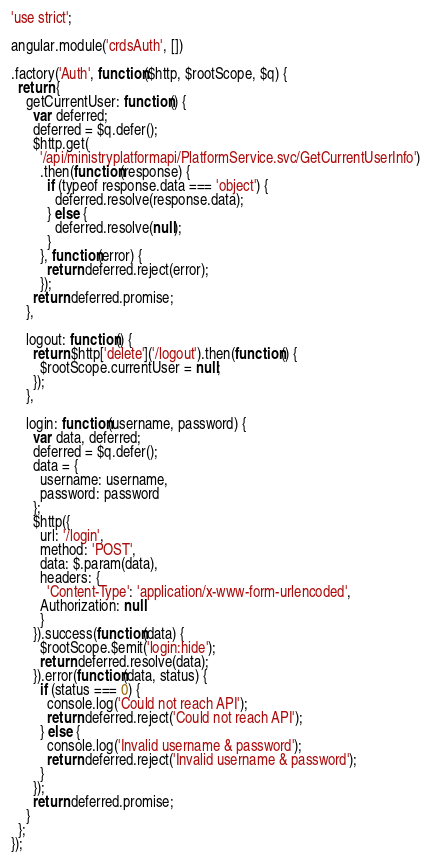<code> <loc_0><loc_0><loc_500><loc_500><_JavaScript_>'use strict';

angular.module('crdsAuth', [])

.factory('Auth', function($http, $rootScope, $q) {
  return {
    getCurrentUser: function() {
      var deferred;
      deferred = $q.defer();
      $http.get(
        '/api/ministryplatformapi/PlatformService.svc/GetCurrentUserInfo')
        .then(function(response) {
          if (typeof response.data === 'object') {
            deferred.resolve(response.data);
          } else {
            deferred.resolve(null);
          }
        }, function(error) {
          return deferred.reject(error);
        });
      return deferred.promise;
    },

    logout: function() {
      return $http['delete']('/logout').then(function() {
        $rootScope.currentUser = null;
      });
    },

    login: function(username, password) {
      var data, deferred;
      deferred = $q.defer();
      data = {
        username: username,
        password: password
      };
      $http({
        url: '/login',
        method: 'POST',
        data: $.param(data),
        headers: {
          'Content-Type': 'application/x-www-form-urlencoded',
        Authorization: null
        }
      }).success(function(data) {
        $rootScope.$emit('login:hide');
        return deferred.resolve(data);
      }).error(function(data, status) {
        if (status === 0) {
          console.log('Could not reach API');
          return deferred.reject('Could not reach API');
        } else {
          console.log('Invalid username & password');
          return deferred.reject('Invalid username & password');
        }
      });
      return deferred.promise;
    }
  };
});
</code> 